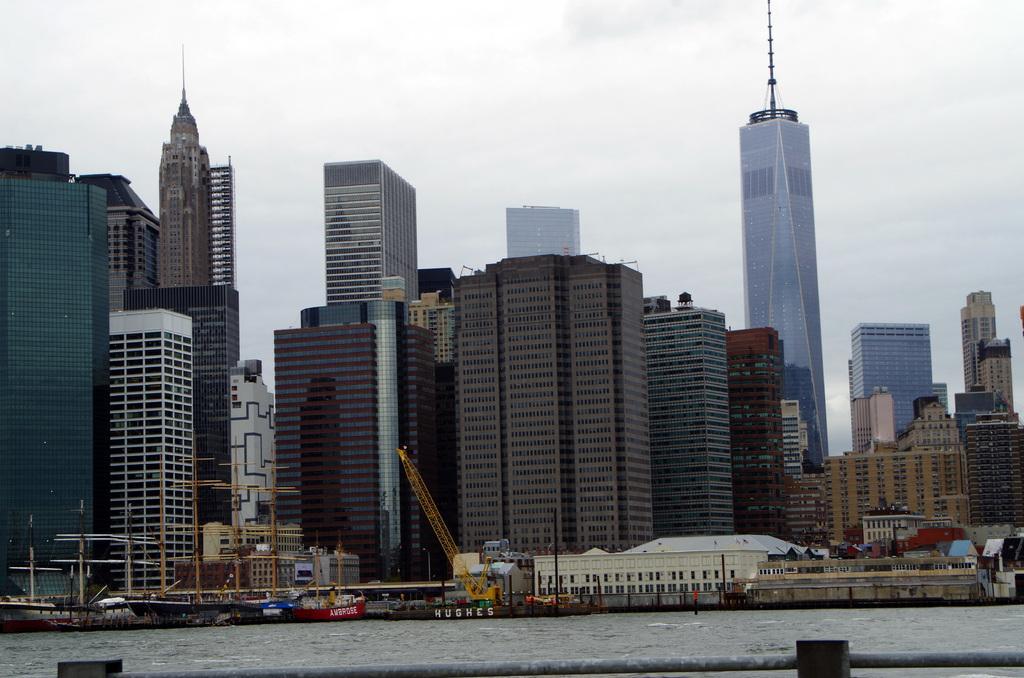Can you describe this image briefly? In this picture we can see a crane, ships in water. We can see a rod. There are few buildings visible in the background from left to right. Sky is cloudy. 